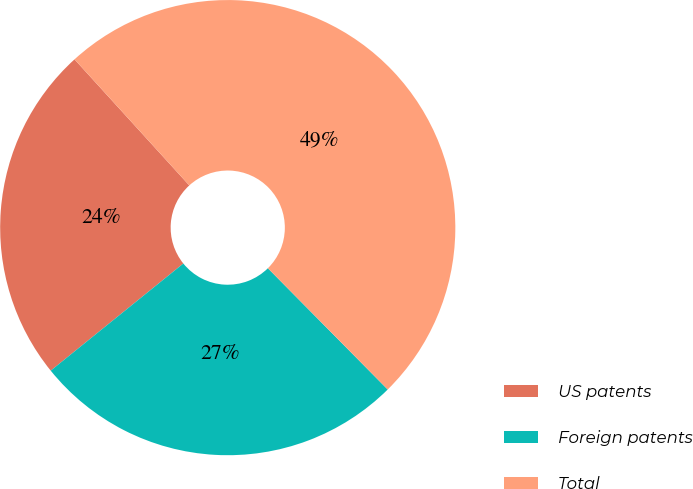Convert chart. <chart><loc_0><loc_0><loc_500><loc_500><pie_chart><fcel>US patents<fcel>Foreign patents<fcel>Total<nl><fcel>24.06%<fcel>26.59%<fcel>49.35%<nl></chart> 